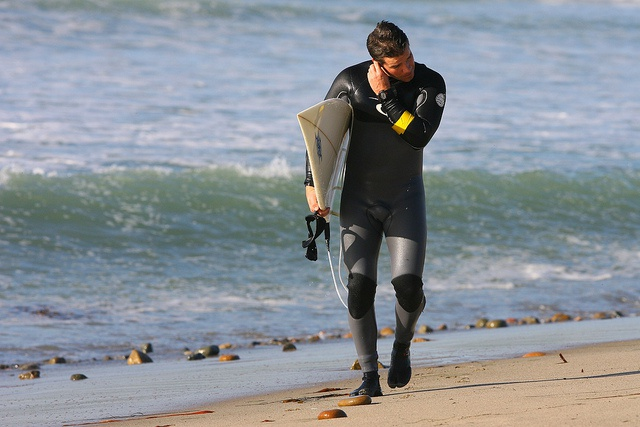Describe the objects in this image and their specific colors. I can see people in gray, black, darkgray, and maroon tones and surfboard in gray and tan tones in this image. 